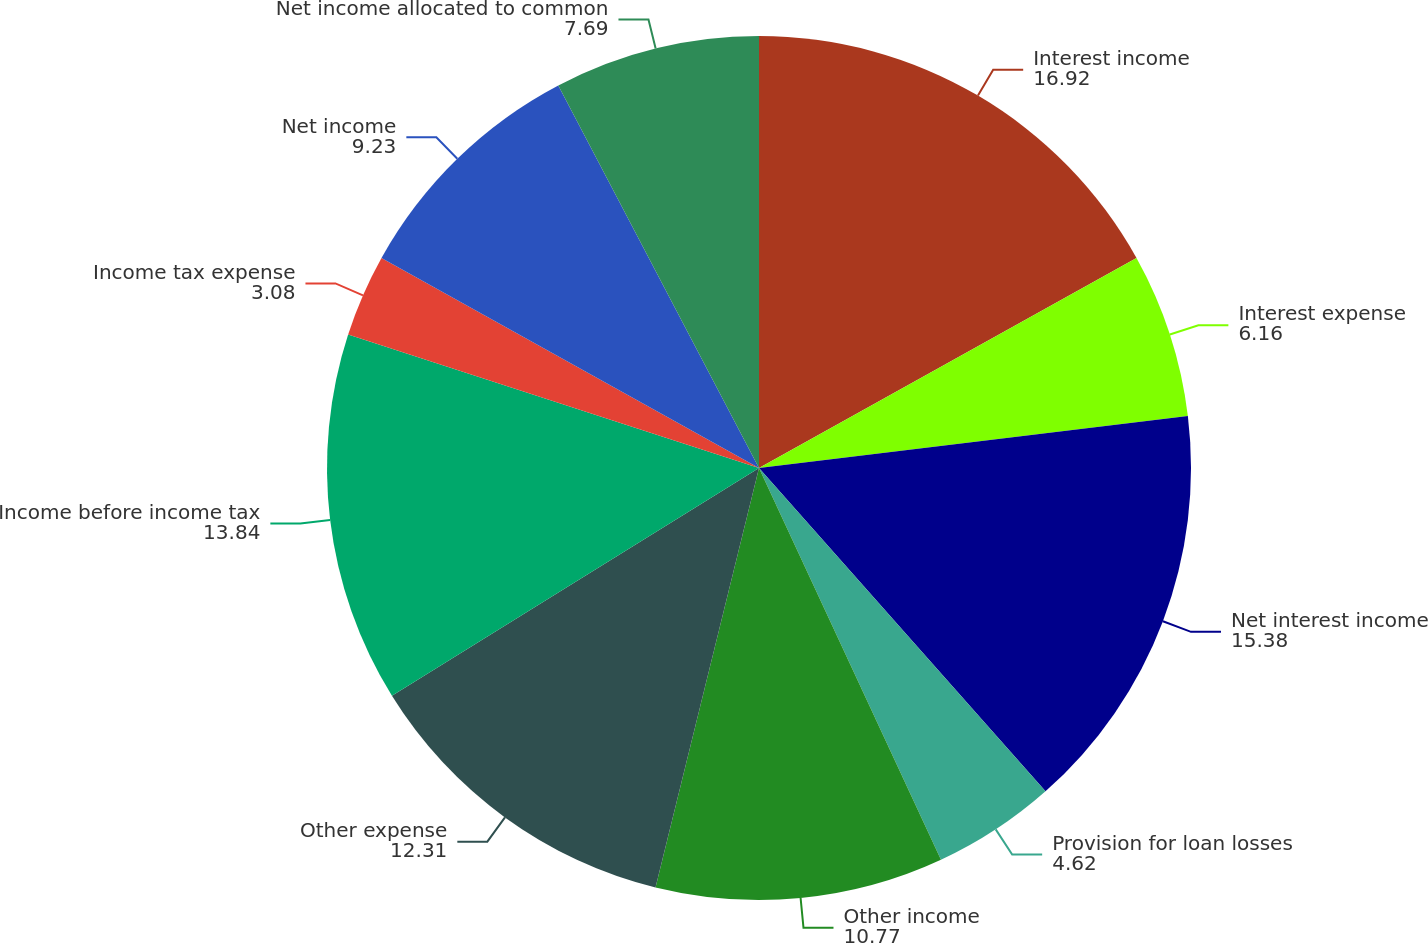Convert chart to OTSL. <chart><loc_0><loc_0><loc_500><loc_500><pie_chart><fcel>Interest income<fcel>Interest expense<fcel>Net interest income<fcel>Provision for loan losses<fcel>Other income<fcel>Other expense<fcel>Income before income tax<fcel>Income tax expense<fcel>Net income<fcel>Net income allocated to common<nl><fcel>16.92%<fcel>6.16%<fcel>15.38%<fcel>4.62%<fcel>10.77%<fcel>12.31%<fcel>13.84%<fcel>3.08%<fcel>9.23%<fcel>7.69%<nl></chart> 